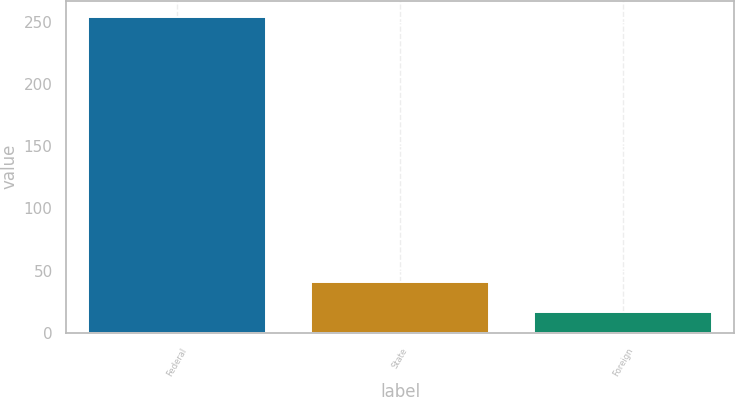Convert chart. <chart><loc_0><loc_0><loc_500><loc_500><bar_chart><fcel>Federal<fcel>State<fcel>Foreign<nl><fcel>254.1<fcel>40.62<fcel>16.9<nl></chart> 